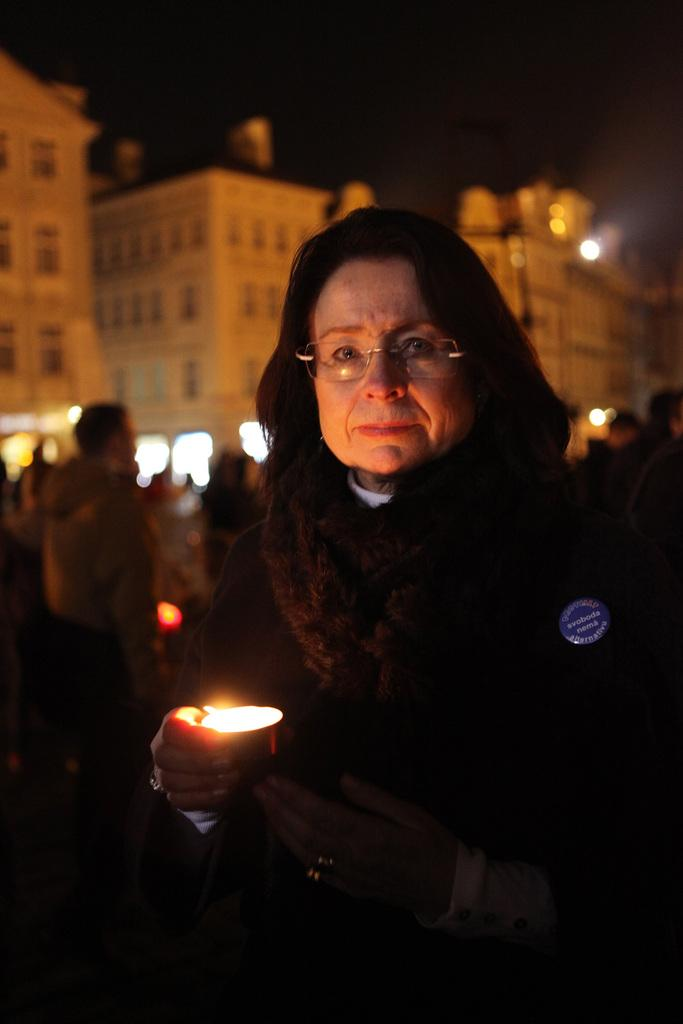What is the main subject of the image? The main subject of the image is a woman standing in the middle. What is the woman holding in the image? The woman is holding a candle. Are there any other people in the image? Yes, there are people standing behind the woman. What can be seen in the background of the image? There are buildings visible in the image. How many straws are being used to play volleyball in the image? There is no volleyball or straws present in the image. 